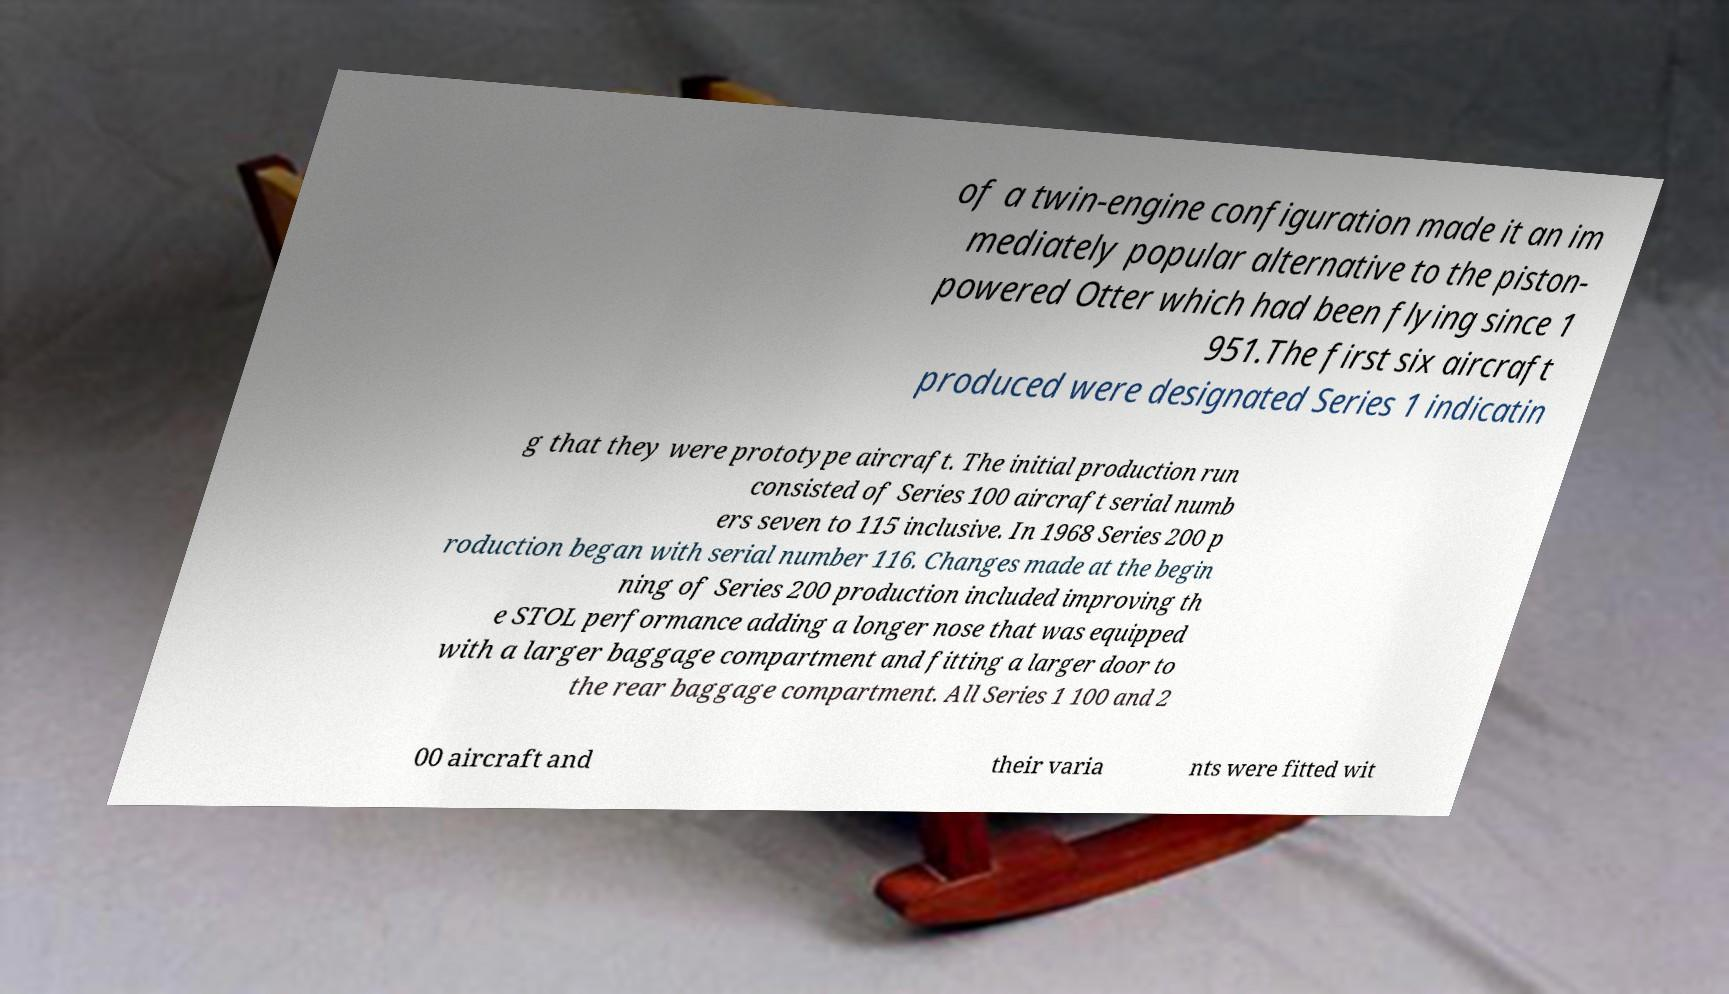I need the written content from this picture converted into text. Can you do that? of a twin-engine configuration made it an im mediately popular alternative to the piston- powered Otter which had been flying since 1 951.The first six aircraft produced were designated Series 1 indicatin g that they were prototype aircraft. The initial production run consisted of Series 100 aircraft serial numb ers seven to 115 inclusive. In 1968 Series 200 p roduction began with serial number 116. Changes made at the begin ning of Series 200 production included improving th e STOL performance adding a longer nose that was equipped with a larger baggage compartment and fitting a larger door to the rear baggage compartment. All Series 1 100 and 2 00 aircraft and their varia nts were fitted wit 